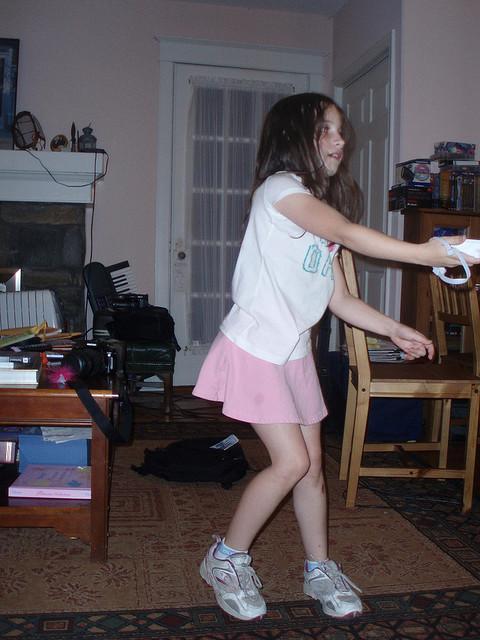How many glass panes on door?
Give a very brief answer. 15. How many chairs can be seen?
Give a very brief answer. 3. 